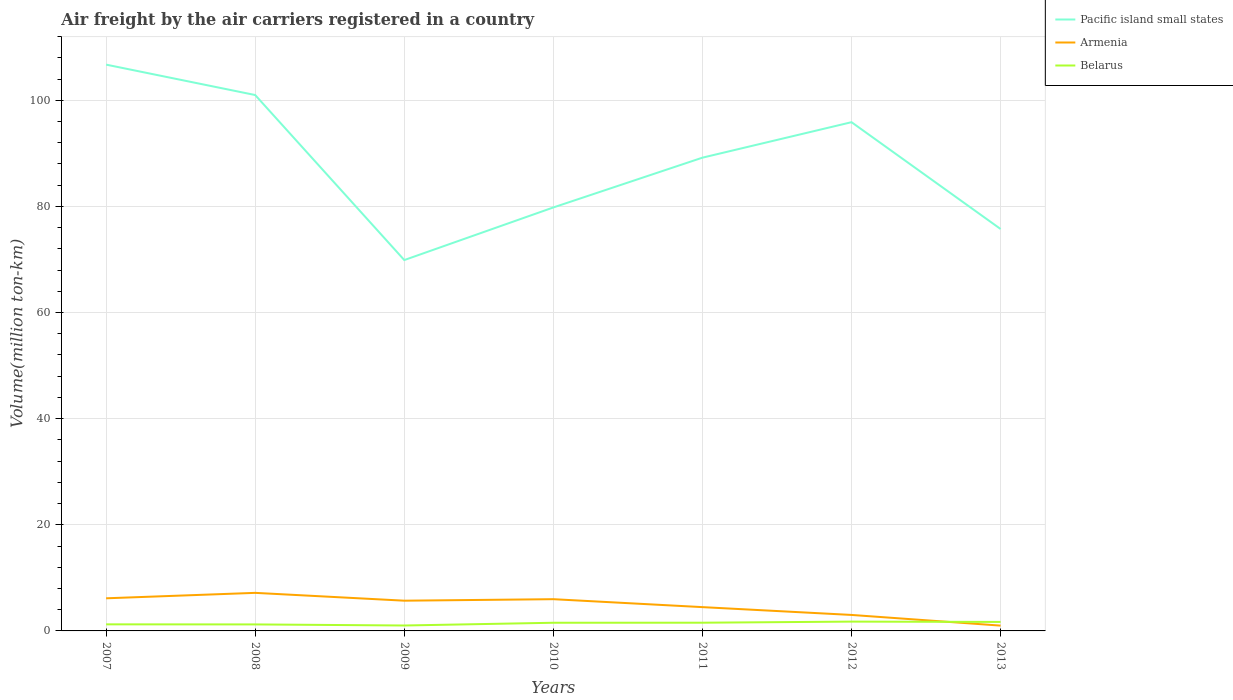What is the total volume of the air carriers in Belarus in the graph?
Your answer should be very brief. -0.53. What is the difference between the highest and the second highest volume of the air carriers in Pacific island small states?
Make the answer very short. 36.83. What is the difference between the highest and the lowest volume of the air carriers in Armenia?
Provide a short and direct response. 4. How many lines are there?
Make the answer very short. 3. How many years are there in the graph?
Keep it short and to the point. 7. What is the difference between two consecutive major ticks on the Y-axis?
Make the answer very short. 20. Are the values on the major ticks of Y-axis written in scientific E-notation?
Offer a terse response. No. Does the graph contain any zero values?
Make the answer very short. No. Where does the legend appear in the graph?
Provide a succinct answer. Top right. What is the title of the graph?
Keep it short and to the point. Air freight by the air carriers registered in a country. What is the label or title of the X-axis?
Offer a terse response. Years. What is the label or title of the Y-axis?
Make the answer very short. Volume(million ton-km). What is the Volume(million ton-km) in Pacific island small states in 2007?
Your answer should be very brief. 106.72. What is the Volume(million ton-km) of Armenia in 2007?
Offer a terse response. 6.15. What is the Volume(million ton-km) in Belarus in 2007?
Ensure brevity in your answer.  1.24. What is the Volume(million ton-km) in Pacific island small states in 2008?
Your response must be concise. 100.99. What is the Volume(million ton-km) of Armenia in 2008?
Provide a succinct answer. 7.17. What is the Volume(million ton-km) in Belarus in 2008?
Your answer should be compact. 1.23. What is the Volume(million ton-km) of Pacific island small states in 2009?
Your answer should be very brief. 69.89. What is the Volume(million ton-km) of Armenia in 2009?
Offer a very short reply. 5.7. What is the Volume(million ton-km) of Pacific island small states in 2010?
Make the answer very short. 79.81. What is the Volume(million ton-km) of Armenia in 2010?
Give a very brief answer. 5.98. What is the Volume(million ton-km) in Belarus in 2010?
Offer a very short reply. 1.54. What is the Volume(million ton-km) in Pacific island small states in 2011?
Ensure brevity in your answer.  89.19. What is the Volume(million ton-km) in Armenia in 2011?
Ensure brevity in your answer.  4.49. What is the Volume(million ton-km) in Belarus in 2011?
Make the answer very short. 1.55. What is the Volume(million ton-km) in Pacific island small states in 2012?
Your answer should be very brief. 95.87. What is the Volume(million ton-km) of Armenia in 2012?
Your answer should be compact. 3.01. What is the Volume(million ton-km) in Belarus in 2012?
Provide a succinct answer. 1.75. What is the Volume(million ton-km) in Pacific island small states in 2013?
Provide a succinct answer. 75.74. What is the Volume(million ton-km) of Belarus in 2013?
Your answer should be very brief. 1.7. Across all years, what is the maximum Volume(million ton-km) of Pacific island small states?
Offer a very short reply. 106.72. Across all years, what is the maximum Volume(million ton-km) in Armenia?
Offer a very short reply. 7.17. Across all years, what is the maximum Volume(million ton-km) in Belarus?
Your answer should be very brief. 1.75. Across all years, what is the minimum Volume(million ton-km) in Pacific island small states?
Your answer should be very brief. 69.89. Across all years, what is the minimum Volume(million ton-km) of Belarus?
Keep it short and to the point. 1.02. What is the total Volume(million ton-km) in Pacific island small states in the graph?
Provide a succinct answer. 618.22. What is the total Volume(million ton-km) of Armenia in the graph?
Give a very brief answer. 33.5. What is the total Volume(million ton-km) of Belarus in the graph?
Give a very brief answer. 10.03. What is the difference between the Volume(million ton-km) of Pacific island small states in 2007 and that in 2008?
Provide a succinct answer. 5.73. What is the difference between the Volume(million ton-km) of Armenia in 2007 and that in 2008?
Your answer should be compact. -1.03. What is the difference between the Volume(million ton-km) in Belarus in 2007 and that in 2008?
Keep it short and to the point. 0.01. What is the difference between the Volume(million ton-km) of Pacific island small states in 2007 and that in 2009?
Offer a terse response. 36.83. What is the difference between the Volume(million ton-km) in Armenia in 2007 and that in 2009?
Provide a short and direct response. 0.45. What is the difference between the Volume(million ton-km) of Belarus in 2007 and that in 2009?
Your answer should be very brief. 0.22. What is the difference between the Volume(million ton-km) in Pacific island small states in 2007 and that in 2010?
Your response must be concise. 26.92. What is the difference between the Volume(million ton-km) in Armenia in 2007 and that in 2010?
Your answer should be compact. 0.17. What is the difference between the Volume(million ton-km) in Pacific island small states in 2007 and that in 2011?
Make the answer very short. 17.53. What is the difference between the Volume(million ton-km) in Armenia in 2007 and that in 2011?
Give a very brief answer. 1.66. What is the difference between the Volume(million ton-km) of Belarus in 2007 and that in 2011?
Offer a terse response. -0.31. What is the difference between the Volume(million ton-km) in Pacific island small states in 2007 and that in 2012?
Give a very brief answer. 10.85. What is the difference between the Volume(million ton-km) of Armenia in 2007 and that in 2012?
Ensure brevity in your answer.  3.14. What is the difference between the Volume(million ton-km) of Belarus in 2007 and that in 2012?
Offer a very short reply. -0.52. What is the difference between the Volume(million ton-km) in Pacific island small states in 2007 and that in 2013?
Your answer should be very brief. 30.98. What is the difference between the Volume(million ton-km) of Armenia in 2007 and that in 2013?
Offer a terse response. 5.15. What is the difference between the Volume(million ton-km) of Belarus in 2007 and that in 2013?
Provide a short and direct response. -0.46. What is the difference between the Volume(million ton-km) of Pacific island small states in 2008 and that in 2009?
Make the answer very short. 31.1. What is the difference between the Volume(million ton-km) in Armenia in 2008 and that in 2009?
Your response must be concise. 1.48. What is the difference between the Volume(million ton-km) of Belarus in 2008 and that in 2009?
Give a very brief answer. 0.2. What is the difference between the Volume(million ton-km) in Pacific island small states in 2008 and that in 2010?
Your response must be concise. 21.19. What is the difference between the Volume(million ton-km) in Armenia in 2008 and that in 2010?
Your answer should be compact. 1.19. What is the difference between the Volume(million ton-km) of Belarus in 2008 and that in 2010?
Your response must be concise. -0.31. What is the difference between the Volume(million ton-km) of Pacific island small states in 2008 and that in 2011?
Make the answer very short. 11.8. What is the difference between the Volume(million ton-km) of Armenia in 2008 and that in 2011?
Provide a succinct answer. 2.69. What is the difference between the Volume(million ton-km) in Belarus in 2008 and that in 2011?
Offer a very short reply. -0.32. What is the difference between the Volume(million ton-km) in Pacific island small states in 2008 and that in 2012?
Offer a terse response. 5.12. What is the difference between the Volume(million ton-km) in Armenia in 2008 and that in 2012?
Your answer should be very brief. 4.16. What is the difference between the Volume(million ton-km) of Belarus in 2008 and that in 2012?
Offer a terse response. -0.53. What is the difference between the Volume(million ton-km) in Pacific island small states in 2008 and that in 2013?
Offer a very short reply. 25.25. What is the difference between the Volume(million ton-km) of Armenia in 2008 and that in 2013?
Offer a terse response. 6.17. What is the difference between the Volume(million ton-km) in Belarus in 2008 and that in 2013?
Give a very brief answer. -0.47. What is the difference between the Volume(million ton-km) of Pacific island small states in 2009 and that in 2010?
Offer a terse response. -9.92. What is the difference between the Volume(million ton-km) in Armenia in 2009 and that in 2010?
Give a very brief answer. -0.28. What is the difference between the Volume(million ton-km) in Belarus in 2009 and that in 2010?
Make the answer very short. -0.52. What is the difference between the Volume(million ton-km) of Pacific island small states in 2009 and that in 2011?
Ensure brevity in your answer.  -19.3. What is the difference between the Volume(million ton-km) in Armenia in 2009 and that in 2011?
Your response must be concise. 1.21. What is the difference between the Volume(million ton-km) in Belarus in 2009 and that in 2011?
Your response must be concise. -0.53. What is the difference between the Volume(million ton-km) in Pacific island small states in 2009 and that in 2012?
Provide a short and direct response. -25.98. What is the difference between the Volume(million ton-km) of Armenia in 2009 and that in 2012?
Ensure brevity in your answer.  2.69. What is the difference between the Volume(million ton-km) of Belarus in 2009 and that in 2012?
Provide a succinct answer. -0.73. What is the difference between the Volume(million ton-km) in Pacific island small states in 2009 and that in 2013?
Ensure brevity in your answer.  -5.85. What is the difference between the Volume(million ton-km) of Armenia in 2009 and that in 2013?
Your answer should be compact. 4.7. What is the difference between the Volume(million ton-km) in Belarus in 2009 and that in 2013?
Offer a very short reply. -0.67. What is the difference between the Volume(million ton-km) of Pacific island small states in 2010 and that in 2011?
Offer a terse response. -9.38. What is the difference between the Volume(million ton-km) in Armenia in 2010 and that in 2011?
Offer a very short reply. 1.49. What is the difference between the Volume(million ton-km) in Belarus in 2010 and that in 2011?
Ensure brevity in your answer.  -0.01. What is the difference between the Volume(million ton-km) of Pacific island small states in 2010 and that in 2012?
Your answer should be very brief. -16.07. What is the difference between the Volume(million ton-km) of Armenia in 2010 and that in 2012?
Give a very brief answer. 2.97. What is the difference between the Volume(million ton-km) of Belarus in 2010 and that in 2012?
Your answer should be compact. -0.22. What is the difference between the Volume(million ton-km) in Pacific island small states in 2010 and that in 2013?
Give a very brief answer. 4.07. What is the difference between the Volume(million ton-km) in Armenia in 2010 and that in 2013?
Your response must be concise. 4.98. What is the difference between the Volume(million ton-km) of Belarus in 2010 and that in 2013?
Your response must be concise. -0.16. What is the difference between the Volume(million ton-km) in Pacific island small states in 2011 and that in 2012?
Offer a very short reply. -6.68. What is the difference between the Volume(million ton-km) of Armenia in 2011 and that in 2012?
Your answer should be very brief. 1.47. What is the difference between the Volume(million ton-km) in Belarus in 2011 and that in 2012?
Offer a terse response. -0.21. What is the difference between the Volume(million ton-km) of Pacific island small states in 2011 and that in 2013?
Your answer should be very brief. 13.45. What is the difference between the Volume(million ton-km) of Armenia in 2011 and that in 2013?
Make the answer very short. 3.49. What is the difference between the Volume(million ton-km) of Belarus in 2011 and that in 2013?
Offer a terse response. -0.15. What is the difference between the Volume(million ton-km) of Pacific island small states in 2012 and that in 2013?
Your answer should be very brief. 20.13. What is the difference between the Volume(million ton-km) of Armenia in 2012 and that in 2013?
Your answer should be compact. 2.01. What is the difference between the Volume(million ton-km) of Belarus in 2012 and that in 2013?
Your answer should be very brief. 0.06. What is the difference between the Volume(million ton-km) of Pacific island small states in 2007 and the Volume(million ton-km) of Armenia in 2008?
Your answer should be very brief. 99.55. What is the difference between the Volume(million ton-km) in Pacific island small states in 2007 and the Volume(million ton-km) in Belarus in 2008?
Your response must be concise. 105.5. What is the difference between the Volume(million ton-km) of Armenia in 2007 and the Volume(million ton-km) of Belarus in 2008?
Your answer should be very brief. 4.92. What is the difference between the Volume(million ton-km) in Pacific island small states in 2007 and the Volume(million ton-km) in Armenia in 2009?
Keep it short and to the point. 101.03. What is the difference between the Volume(million ton-km) of Pacific island small states in 2007 and the Volume(million ton-km) of Belarus in 2009?
Your response must be concise. 105.7. What is the difference between the Volume(million ton-km) of Armenia in 2007 and the Volume(million ton-km) of Belarus in 2009?
Provide a short and direct response. 5.13. What is the difference between the Volume(million ton-km) of Pacific island small states in 2007 and the Volume(million ton-km) of Armenia in 2010?
Keep it short and to the point. 100.74. What is the difference between the Volume(million ton-km) in Pacific island small states in 2007 and the Volume(million ton-km) in Belarus in 2010?
Offer a very short reply. 105.18. What is the difference between the Volume(million ton-km) in Armenia in 2007 and the Volume(million ton-km) in Belarus in 2010?
Your response must be concise. 4.61. What is the difference between the Volume(million ton-km) of Pacific island small states in 2007 and the Volume(million ton-km) of Armenia in 2011?
Your answer should be compact. 102.24. What is the difference between the Volume(million ton-km) of Pacific island small states in 2007 and the Volume(million ton-km) of Belarus in 2011?
Your response must be concise. 105.17. What is the difference between the Volume(million ton-km) in Armenia in 2007 and the Volume(million ton-km) in Belarus in 2011?
Make the answer very short. 4.6. What is the difference between the Volume(million ton-km) of Pacific island small states in 2007 and the Volume(million ton-km) of Armenia in 2012?
Your answer should be very brief. 103.71. What is the difference between the Volume(million ton-km) in Pacific island small states in 2007 and the Volume(million ton-km) in Belarus in 2012?
Make the answer very short. 104.97. What is the difference between the Volume(million ton-km) of Armenia in 2007 and the Volume(million ton-km) of Belarus in 2012?
Your answer should be compact. 4.39. What is the difference between the Volume(million ton-km) of Pacific island small states in 2007 and the Volume(million ton-km) of Armenia in 2013?
Offer a terse response. 105.72. What is the difference between the Volume(million ton-km) in Pacific island small states in 2007 and the Volume(million ton-km) in Belarus in 2013?
Make the answer very short. 105.03. What is the difference between the Volume(million ton-km) of Armenia in 2007 and the Volume(million ton-km) of Belarus in 2013?
Provide a succinct answer. 4.45. What is the difference between the Volume(million ton-km) of Pacific island small states in 2008 and the Volume(million ton-km) of Armenia in 2009?
Your answer should be compact. 95.3. What is the difference between the Volume(million ton-km) of Pacific island small states in 2008 and the Volume(million ton-km) of Belarus in 2009?
Ensure brevity in your answer.  99.97. What is the difference between the Volume(million ton-km) in Armenia in 2008 and the Volume(million ton-km) in Belarus in 2009?
Ensure brevity in your answer.  6.15. What is the difference between the Volume(million ton-km) of Pacific island small states in 2008 and the Volume(million ton-km) of Armenia in 2010?
Make the answer very short. 95.01. What is the difference between the Volume(million ton-km) of Pacific island small states in 2008 and the Volume(million ton-km) of Belarus in 2010?
Your response must be concise. 99.45. What is the difference between the Volume(million ton-km) of Armenia in 2008 and the Volume(million ton-km) of Belarus in 2010?
Ensure brevity in your answer.  5.63. What is the difference between the Volume(million ton-km) in Pacific island small states in 2008 and the Volume(million ton-km) in Armenia in 2011?
Make the answer very short. 96.51. What is the difference between the Volume(million ton-km) of Pacific island small states in 2008 and the Volume(million ton-km) of Belarus in 2011?
Your answer should be very brief. 99.44. What is the difference between the Volume(million ton-km) in Armenia in 2008 and the Volume(million ton-km) in Belarus in 2011?
Offer a very short reply. 5.62. What is the difference between the Volume(million ton-km) of Pacific island small states in 2008 and the Volume(million ton-km) of Armenia in 2012?
Give a very brief answer. 97.98. What is the difference between the Volume(million ton-km) in Pacific island small states in 2008 and the Volume(million ton-km) in Belarus in 2012?
Provide a short and direct response. 99.24. What is the difference between the Volume(million ton-km) of Armenia in 2008 and the Volume(million ton-km) of Belarus in 2012?
Provide a succinct answer. 5.42. What is the difference between the Volume(million ton-km) of Pacific island small states in 2008 and the Volume(million ton-km) of Armenia in 2013?
Provide a short and direct response. 99.99. What is the difference between the Volume(million ton-km) in Pacific island small states in 2008 and the Volume(million ton-km) in Belarus in 2013?
Provide a succinct answer. 99.3. What is the difference between the Volume(million ton-km) in Armenia in 2008 and the Volume(million ton-km) in Belarus in 2013?
Provide a succinct answer. 5.48. What is the difference between the Volume(million ton-km) of Pacific island small states in 2009 and the Volume(million ton-km) of Armenia in 2010?
Your answer should be very brief. 63.91. What is the difference between the Volume(million ton-km) in Pacific island small states in 2009 and the Volume(million ton-km) in Belarus in 2010?
Provide a short and direct response. 68.35. What is the difference between the Volume(million ton-km) in Armenia in 2009 and the Volume(million ton-km) in Belarus in 2010?
Make the answer very short. 4.16. What is the difference between the Volume(million ton-km) of Pacific island small states in 2009 and the Volume(million ton-km) of Armenia in 2011?
Provide a succinct answer. 65.41. What is the difference between the Volume(million ton-km) in Pacific island small states in 2009 and the Volume(million ton-km) in Belarus in 2011?
Provide a short and direct response. 68.34. What is the difference between the Volume(million ton-km) in Armenia in 2009 and the Volume(million ton-km) in Belarus in 2011?
Provide a short and direct response. 4.15. What is the difference between the Volume(million ton-km) in Pacific island small states in 2009 and the Volume(million ton-km) in Armenia in 2012?
Keep it short and to the point. 66.88. What is the difference between the Volume(million ton-km) in Pacific island small states in 2009 and the Volume(million ton-km) in Belarus in 2012?
Your answer should be very brief. 68.14. What is the difference between the Volume(million ton-km) in Armenia in 2009 and the Volume(million ton-km) in Belarus in 2012?
Offer a very short reply. 3.94. What is the difference between the Volume(million ton-km) of Pacific island small states in 2009 and the Volume(million ton-km) of Armenia in 2013?
Make the answer very short. 68.89. What is the difference between the Volume(million ton-km) in Pacific island small states in 2009 and the Volume(million ton-km) in Belarus in 2013?
Offer a terse response. 68.19. What is the difference between the Volume(million ton-km) of Armenia in 2009 and the Volume(million ton-km) of Belarus in 2013?
Offer a very short reply. 4. What is the difference between the Volume(million ton-km) in Pacific island small states in 2010 and the Volume(million ton-km) in Armenia in 2011?
Your answer should be very brief. 75.32. What is the difference between the Volume(million ton-km) of Pacific island small states in 2010 and the Volume(million ton-km) of Belarus in 2011?
Give a very brief answer. 78.26. What is the difference between the Volume(million ton-km) of Armenia in 2010 and the Volume(million ton-km) of Belarus in 2011?
Keep it short and to the point. 4.43. What is the difference between the Volume(million ton-km) of Pacific island small states in 2010 and the Volume(million ton-km) of Armenia in 2012?
Your answer should be compact. 76.8. What is the difference between the Volume(million ton-km) in Pacific island small states in 2010 and the Volume(million ton-km) in Belarus in 2012?
Your response must be concise. 78.05. What is the difference between the Volume(million ton-km) of Armenia in 2010 and the Volume(million ton-km) of Belarus in 2012?
Provide a short and direct response. 4.22. What is the difference between the Volume(million ton-km) in Pacific island small states in 2010 and the Volume(million ton-km) in Armenia in 2013?
Keep it short and to the point. 78.81. What is the difference between the Volume(million ton-km) in Pacific island small states in 2010 and the Volume(million ton-km) in Belarus in 2013?
Give a very brief answer. 78.11. What is the difference between the Volume(million ton-km) of Armenia in 2010 and the Volume(million ton-km) of Belarus in 2013?
Your answer should be compact. 4.28. What is the difference between the Volume(million ton-km) in Pacific island small states in 2011 and the Volume(million ton-km) in Armenia in 2012?
Make the answer very short. 86.18. What is the difference between the Volume(million ton-km) of Pacific island small states in 2011 and the Volume(million ton-km) of Belarus in 2012?
Your response must be concise. 87.43. What is the difference between the Volume(million ton-km) of Armenia in 2011 and the Volume(million ton-km) of Belarus in 2012?
Provide a succinct answer. 2.73. What is the difference between the Volume(million ton-km) in Pacific island small states in 2011 and the Volume(million ton-km) in Armenia in 2013?
Provide a succinct answer. 88.19. What is the difference between the Volume(million ton-km) in Pacific island small states in 2011 and the Volume(million ton-km) in Belarus in 2013?
Keep it short and to the point. 87.49. What is the difference between the Volume(million ton-km) in Armenia in 2011 and the Volume(million ton-km) in Belarus in 2013?
Keep it short and to the point. 2.79. What is the difference between the Volume(million ton-km) of Pacific island small states in 2012 and the Volume(million ton-km) of Armenia in 2013?
Give a very brief answer. 94.87. What is the difference between the Volume(million ton-km) in Pacific island small states in 2012 and the Volume(million ton-km) in Belarus in 2013?
Your answer should be very brief. 94.18. What is the difference between the Volume(million ton-km) in Armenia in 2012 and the Volume(million ton-km) in Belarus in 2013?
Offer a very short reply. 1.32. What is the average Volume(million ton-km) of Pacific island small states per year?
Ensure brevity in your answer.  88.32. What is the average Volume(million ton-km) of Armenia per year?
Make the answer very short. 4.79. What is the average Volume(million ton-km) of Belarus per year?
Your answer should be very brief. 1.43. In the year 2007, what is the difference between the Volume(million ton-km) of Pacific island small states and Volume(million ton-km) of Armenia?
Offer a terse response. 100.58. In the year 2007, what is the difference between the Volume(million ton-km) in Pacific island small states and Volume(million ton-km) in Belarus?
Offer a very short reply. 105.48. In the year 2007, what is the difference between the Volume(million ton-km) of Armenia and Volume(million ton-km) of Belarus?
Your answer should be compact. 4.91. In the year 2008, what is the difference between the Volume(million ton-km) of Pacific island small states and Volume(million ton-km) of Armenia?
Provide a succinct answer. 93.82. In the year 2008, what is the difference between the Volume(million ton-km) in Pacific island small states and Volume(million ton-km) in Belarus?
Your answer should be very brief. 99.77. In the year 2008, what is the difference between the Volume(million ton-km) in Armenia and Volume(million ton-km) in Belarus?
Make the answer very short. 5.95. In the year 2009, what is the difference between the Volume(million ton-km) in Pacific island small states and Volume(million ton-km) in Armenia?
Offer a very short reply. 64.19. In the year 2009, what is the difference between the Volume(million ton-km) in Pacific island small states and Volume(million ton-km) in Belarus?
Make the answer very short. 68.87. In the year 2009, what is the difference between the Volume(million ton-km) in Armenia and Volume(million ton-km) in Belarus?
Offer a terse response. 4.68. In the year 2010, what is the difference between the Volume(million ton-km) in Pacific island small states and Volume(million ton-km) in Armenia?
Provide a succinct answer. 73.83. In the year 2010, what is the difference between the Volume(million ton-km) in Pacific island small states and Volume(million ton-km) in Belarus?
Give a very brief answer. 78.27. In the year 2010, what is the difference between the Volume(million ton-km) of Armenia and Volume(million ton-km) of Belarus?
Provide a succinct answer. 4.44. In the year 2011, what is the difference between the Volume(million ton-km) of Pacific island small states and Volume(million ton-km) of Armenia?
Give a very brief answer. 84.7. In the year 2011, what is the difference between the Volume(million ton-km) in Pacific island small states and Volume(million ton-km) in Belarus?
Ensure brevity in your answer.  87.64. In the year 2011, what is the difference between the Volume(million ton-km) of Armenia and Volume(million ton-km) of Belarus?
Your answer should be compact. 2.94. In the year 2012, what is the difference between the Volume(million ton-km) of Pacific island small states and Volume(million ton-km) of Armenia?
Keep it short and to the point. 92.86. In the year 2012, what is the difference between the Volume(million ton-km) of Pacific island small states and Volume(million ton-km) of Belarus?
Your answer should be compact. 94.12. In the year 2012, what is the difference between the Volume(million ton-km) in Armenia and Volume(million ton-km) in Belarus?
Your answer should be very brief. 1.26. In the year 2013, what is the difference between the Volume(million ton-km) in Pacific island small states and Volume(million ton-km) in Armenia?
Give a very brief answer. 74.74. In the year 2013, what is the difference between the Volume(million ton-km) in Pacific island small states and Volume(million ton-km) in Belarus?
Offer a terse response. 74.05. In the year 2013, what is the difference between the Volume(million ton-km) of Armenia and Volume(million ton-km) of Belarus?
Your answer should be very brief. -0.7. What is the ratio of the Volume(million ton-km) of Pacific island small states in 2007 to that in 2008?
Provide a short and direct response. 1.06. What is the ratio of the Volume(million ton-km) of Armenia in 2007 to that in 2008?
Offer a terse response. 0.86. What is the ratio of the Volume(million ton-km) in Belarus in 2007 to that in 2008?
Give a very brief answer. 1.01. What is the ratio of the Volume(million ton-km) of Pacific island small states in 2007 to that in 2009?
Make the answer very short. 1.53. What is the ratio of the Volume(million ton-km) in Armenia in 2007 to that in 2009?
Your answer should be compact. 1.08. What is the ratio of the Volume(million ton-km) in Belarus in 2007 to that in 2009?
Provide a short and direct response. 1.21. What is the ratio of the Volume(million ton-km) of Pacific island small states in 2007 to that in 2010?
Provide a succinct answer. 1.34. What is the ratio of the Volume(million ton-km) of Armenia in 2007 to that in 2010?
Provide a succinct answer. 1.03. What is the ratio of the Volume(million ton-km) in Belarus in 2007 to that in 2010?
Give a very brief answer. 0.81. What is the ratio of the Volume(million ton-km) of Pacific island small states in 2007 to that in 2011?
Ensure brevity in your answer.  1.2. What is the ratio of the Volume(million ton-km) of Armenia in 2007 to that in 2011?
Keep it short and to the point. 1.37. What is the ratio of the Volume(million ton-km) of Belarus in 2007 to that in 2011?
Provide a succinct answer. 0.8. What is the ratio of the Volume(million ton-km) in Pacific island small states in 2007 to that in 2012?
Your answer should be compact. 1.11. What is the ratio of the Volume(million ton-km) of Armenia in 2007 to that in 2012?
Provide a succinct answer. 2.04. What is the ratio of the Volume(million ton-km) in Belarus in 2007 to that in 2012?
Your answer should be compact. 0.71. What is the ratio of the Volume(million ton-km) of Pacific island small states in 2007 to that in 2013?
Keep it short and to the point. 1.41. What is the ratio of the Volume(million ton-km) in Armenia in 2007 to that in 2013?
Ensure brevity in your answer.  6.15. What is the ratio of the Volume(million ton-km) in Belarus in 2007 to that in 2013?
Your response must be concise. 0.73. What is the ratio of the Volume(million ton-km) in Pacific island small states in 2008 to that in 2009?
Offer a terse response. 1.45. What is the ratio of the Volume(million ton-km) in Armenia in 2008 to that in 2009?
Provide a short and direct response. 1.26. What is the ratio of the Volume(million ton-km) of Belarus in 2008 to that in 2009?
Make the answer very short. 1.2. What is the ratio of the Volume(million ton-km) in Pacific island small states in 2008 to that in 2010?
Offer a terse response. 1.27. What is the ratio of the Volume(million ton-km) in Armenia in 2008 to that in 2010?
Give a very brief answer. 1.2. What is the ratio of the Volume(million ton-km) in Belarus in 2008 to that in 2010?
Offer a terse response. 0.8. What is the ratio of the Volume(million ton-km) in Pacific island small states in 2008 to that in 2011?
Offer a terse response. 1.13. What is the ratio of the Volume(million ton-km) of Armenia in 2008 to that in 2011?
Give a very brief answer. 1.6. What is the ratio of the Volume(million ton-km) in Belarus in 2008 to that in 2011?
Your answer should be compact. 0.79. What is the ratio of the Volume(million ton-km) of Pacific island small states in 2008 to that in 2012?
Keep it short and to the point. 1.05. What is the ratio of the Volume(million ton-km) in Armenia in 2008 to that in 2012?
Your response must be concise. 2.38. What is the ratio of the Volume(million ton-km) of Belarus in 2008 to that in 2012?
Ensure brevity in your answer.  0.7. What is the ratio of the Volume(million ton-km) of Pacific island small states in 2008 to that in 2013?
Offer a terse response. 1.33. What is the ratio of the Volume(million ton-km) of Armenia in 2008 to that in 2013?
Your response must be concise. 7.17. What is the ratio of the Volume(million ton-km) of Belarus in 2008 to that in 2013?
Make the answer very short. 0.72. What is the ratio of the Volume(million ton-km) in Pacific island small states in 2009 to that in 2010?
Offer a very short reply. 0.88. What is the ratio of the Volume(million ton-km) of Armenia in 2009 to that in 2010?
Offer a very short reply. 0.95. What is the ratio of the Volume(million ton-km) in Belarus in 2009 to that in 2010?
Provide a succinct answer. 0.66. What is the ratio of the Volume(million ton-km) of Pacific island small states in 2009 to that in 2011?
Your answer should be very brief. 0.78. What is the ratio of the Volume(million ton-km) in Armenia in 2009 to that in 2011?
Offer a terse response. 1.27. What is the ratio of the Volume(million ton-km) in Belarus in 2009 to that in 2011?
Your answer should be very brief. 0.66. What is the ratio of the Volume(million ton-km) in Pacific island small states in 2009 to that in 2012?
Your response must be concise. 0.73. What is the ratio of the Volume(million ton-km) of Armenia in 2009 to that in 2012?
Your answer should be very brief. 1.89. What is the ratio of the Volume(million ton-km) of Belarus in 2009 to that in 2012?
Give a very brief answer. 0.58. What is the ratio of the Volume(million ton-km) in Pacific island small states in 2009 to that in 2013?
Your answer should be compact. 0.92. What is the ratio of the Volume(million ton-km) of Armenia in 2009 to that in 2013?
Ensure brevity in your answer.  5.7. What is the ratio of the Volume(million ton-km) of Belarus in 2009 to that in 2013?
Offer a very short reply. 0.6. What is the ratio of the Volume(million ton-km) of Pacific island small states in 2010 to that in 2011?
Ensure brevity in your answer.  0.89. What is the ratio of the Volume(million ton-km) of Armenia in 2010 to that in 2011?
Your response must be concise. 1.33. What is the ratio of the Volume(million ton-km) of Pacific island small states in 2010 to that in 2012?
Ensure brevity in your answer.  0.83. What is the ratio of the Volume(million ton-km) of Armenia in 2010 to that in 2012?
Provide a succinct answer. 1.99. What is the ratio of the Volume(million ton-km) of Belarus in 2010 to that in 2012?
Your response must be concise. 0.88. What is the ratio of the Volume(million ton-km) in Pacific island small states in 2010 to that in 2013?
Offer a very short reply. 1.05. What is the ratio of the Volume(million ton-km) of Armenia in 2010 to that in 2013?
Your answer should be compact. 5.98. What is the ratio of the Volume(million ton-km) in Belarus in 2010 to that in 2013?
Your answer should be very brief. 0.91. What is the ratio of the Volume(million ton-km) of Pacific island small states in 2011 to that in 2012?
Give a very brief answer. 0.93. What is the ratio of the Volume(million ton-km) in Armenia in 2011 to that in 2012?
Ensure brevity in your answer.  1.49. What is the ratio of the Volume(million ton-km) of Belarus in 2011 to that in 2012?
Ensure brevity in your answer.  0.88. What is the ratio of the Volume(million ton-km) of Pacific island small states in 2011 to that in 2013?
Your answer should be very brief. 1.18. What is the ratio of the Volume(million ton-km) in Armenia in 2011 to that in 2013?
Your answer should be compact. 4.49. What is the ratio of the Volume(million ton-km) of Belarus in 2011 to that in 2013?
Give a very brief answer. 0.91. What is the ratio of the Volume(million ton-km) in Pacific island small states in 2012 to that in 2013?
Your response must be concise. 1.27. What is the ratio of the Volume(million ton-km) of Armenia in 2012 to that in 2013?
Your answer should be very brief. 3.01. What is the ratio of the Volume(million ton-km) in Belarus in 2012 to that in 2013?
Your answer should be compact. 1.03. What is the difference between the highest and the second highest Volume(million ton-km) in Pacific island small states?
Offer a terse response. 5.73. What is the difference between the highest and the second highest Volume(million ton-km) of Armenia?
Your answer should be compact. 1.03. What is the difference between the highest and the second highest Volume(million ton-km) in Belarus?
Keep it short and to the point. 0.06. What is the difference between the highest and the lowest Volume(million ton-km) in Pacific island small states?
Provide a succinct answer. 36.83. What is the difference between the highest and the lowest Volume(million ton-km) in Armenia?
Offer a terse response. 6.17. What is the difference between the highest and the lowest Volume(million ton-km) of Belarus?
Your answer should be very brief. 0.73. 